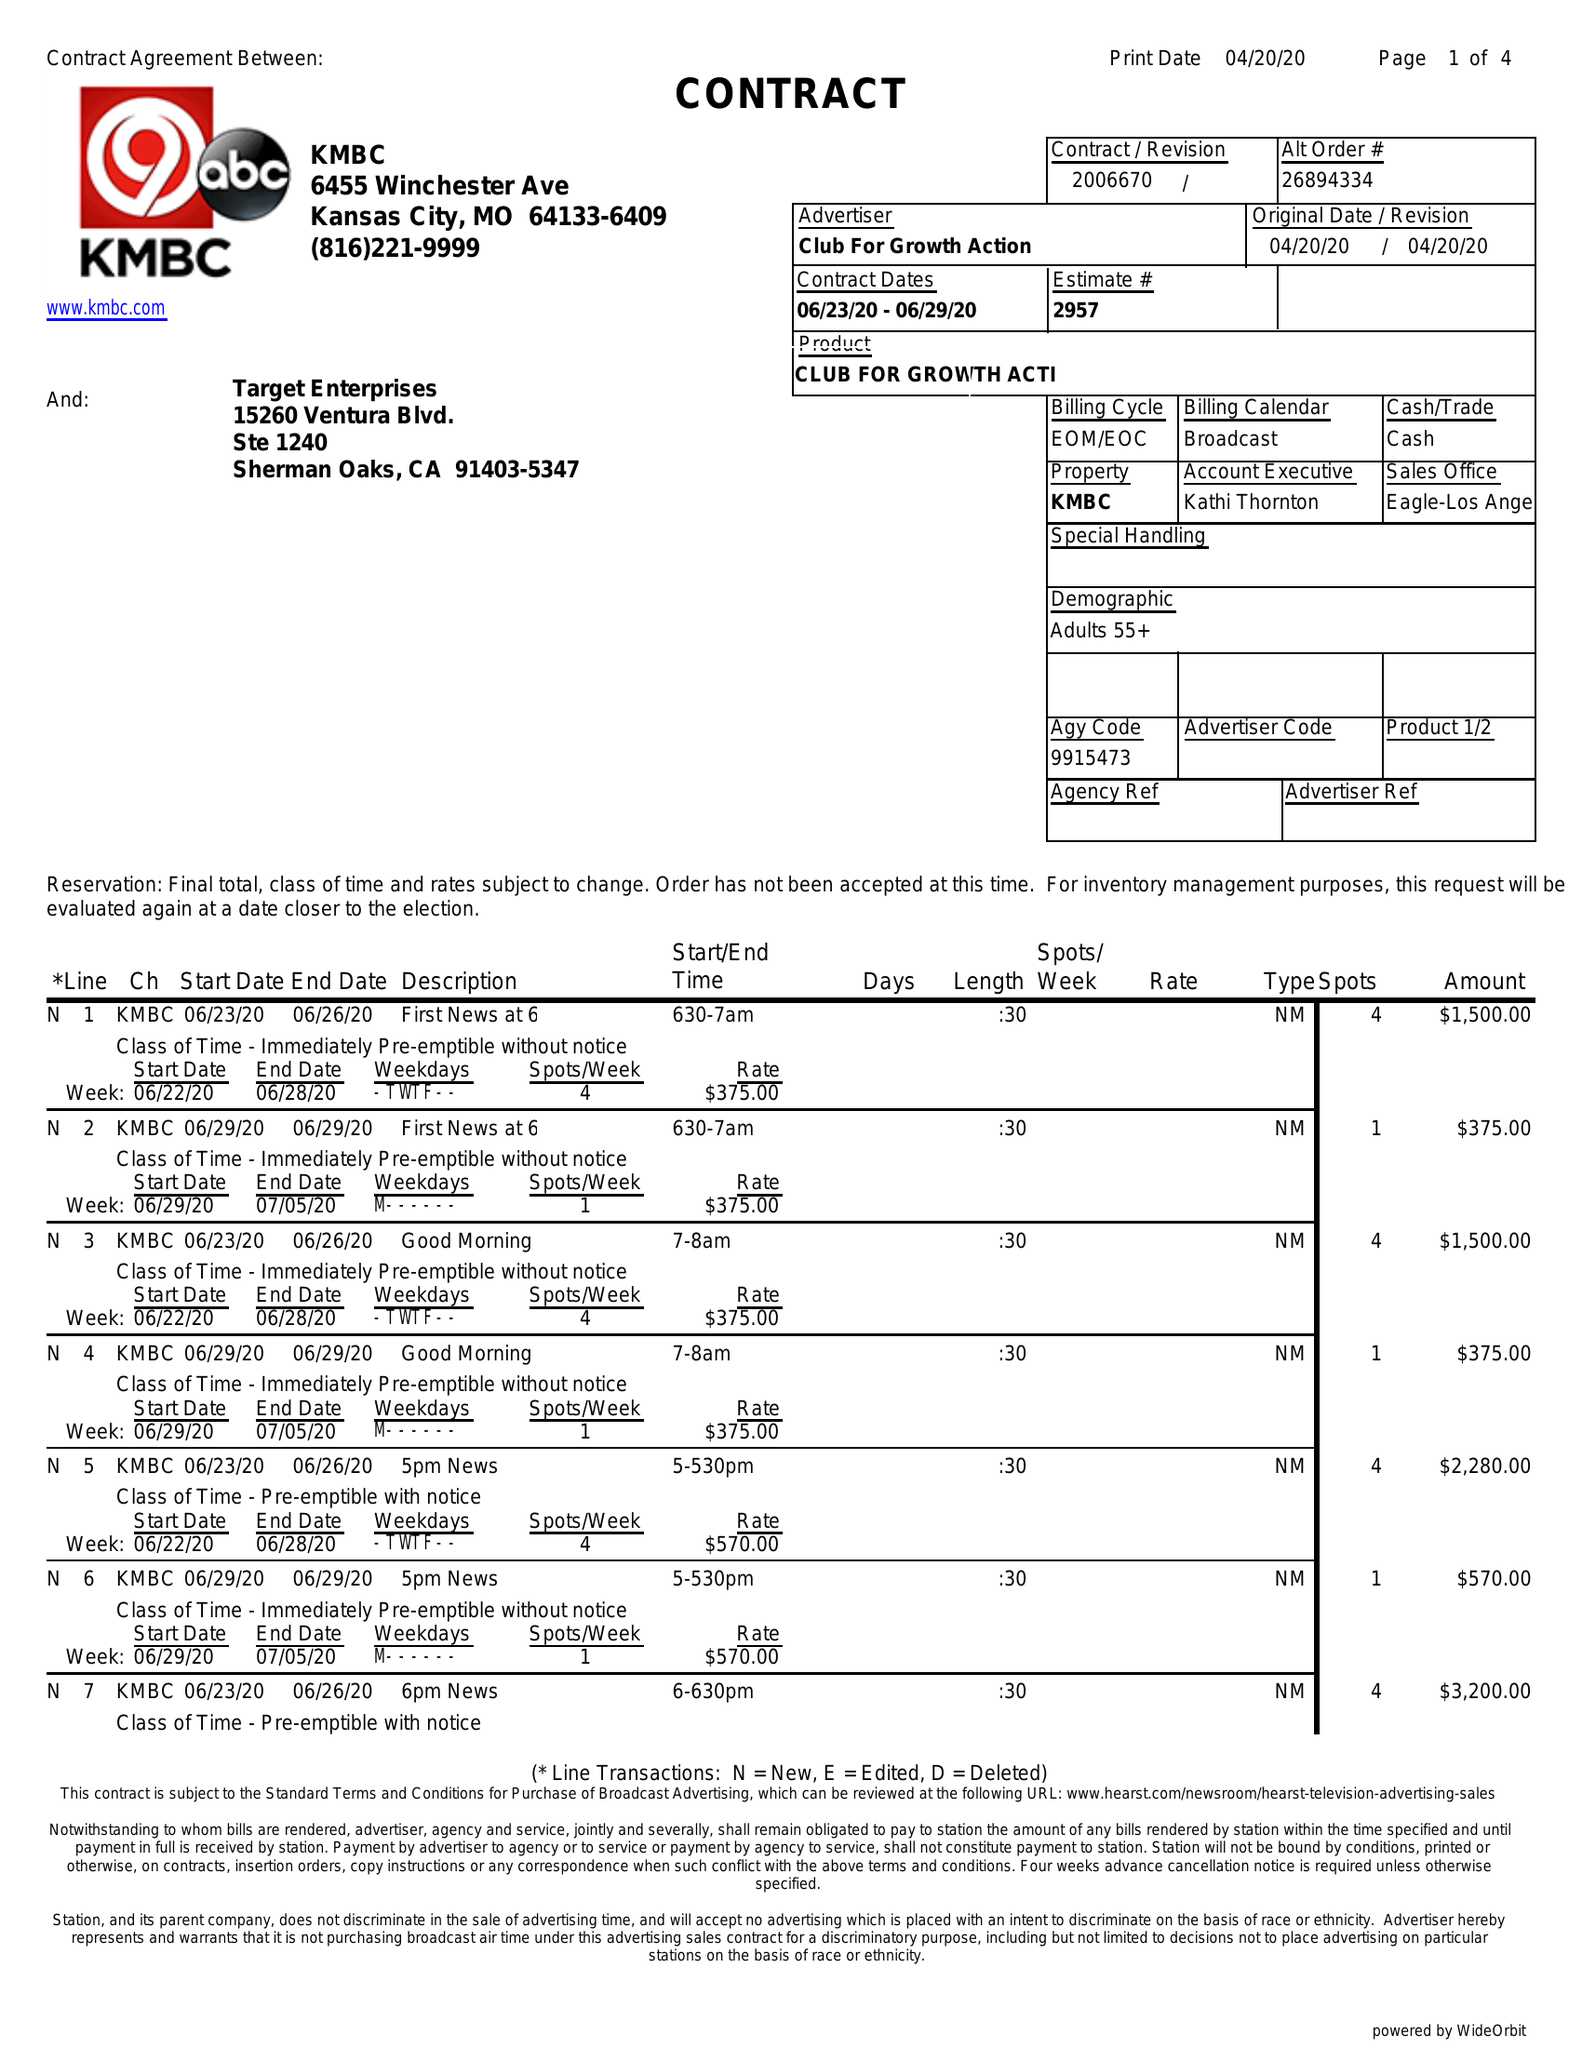What is the value for the flight_from?
Answer the question using a single word or phrase. 06/23/20 